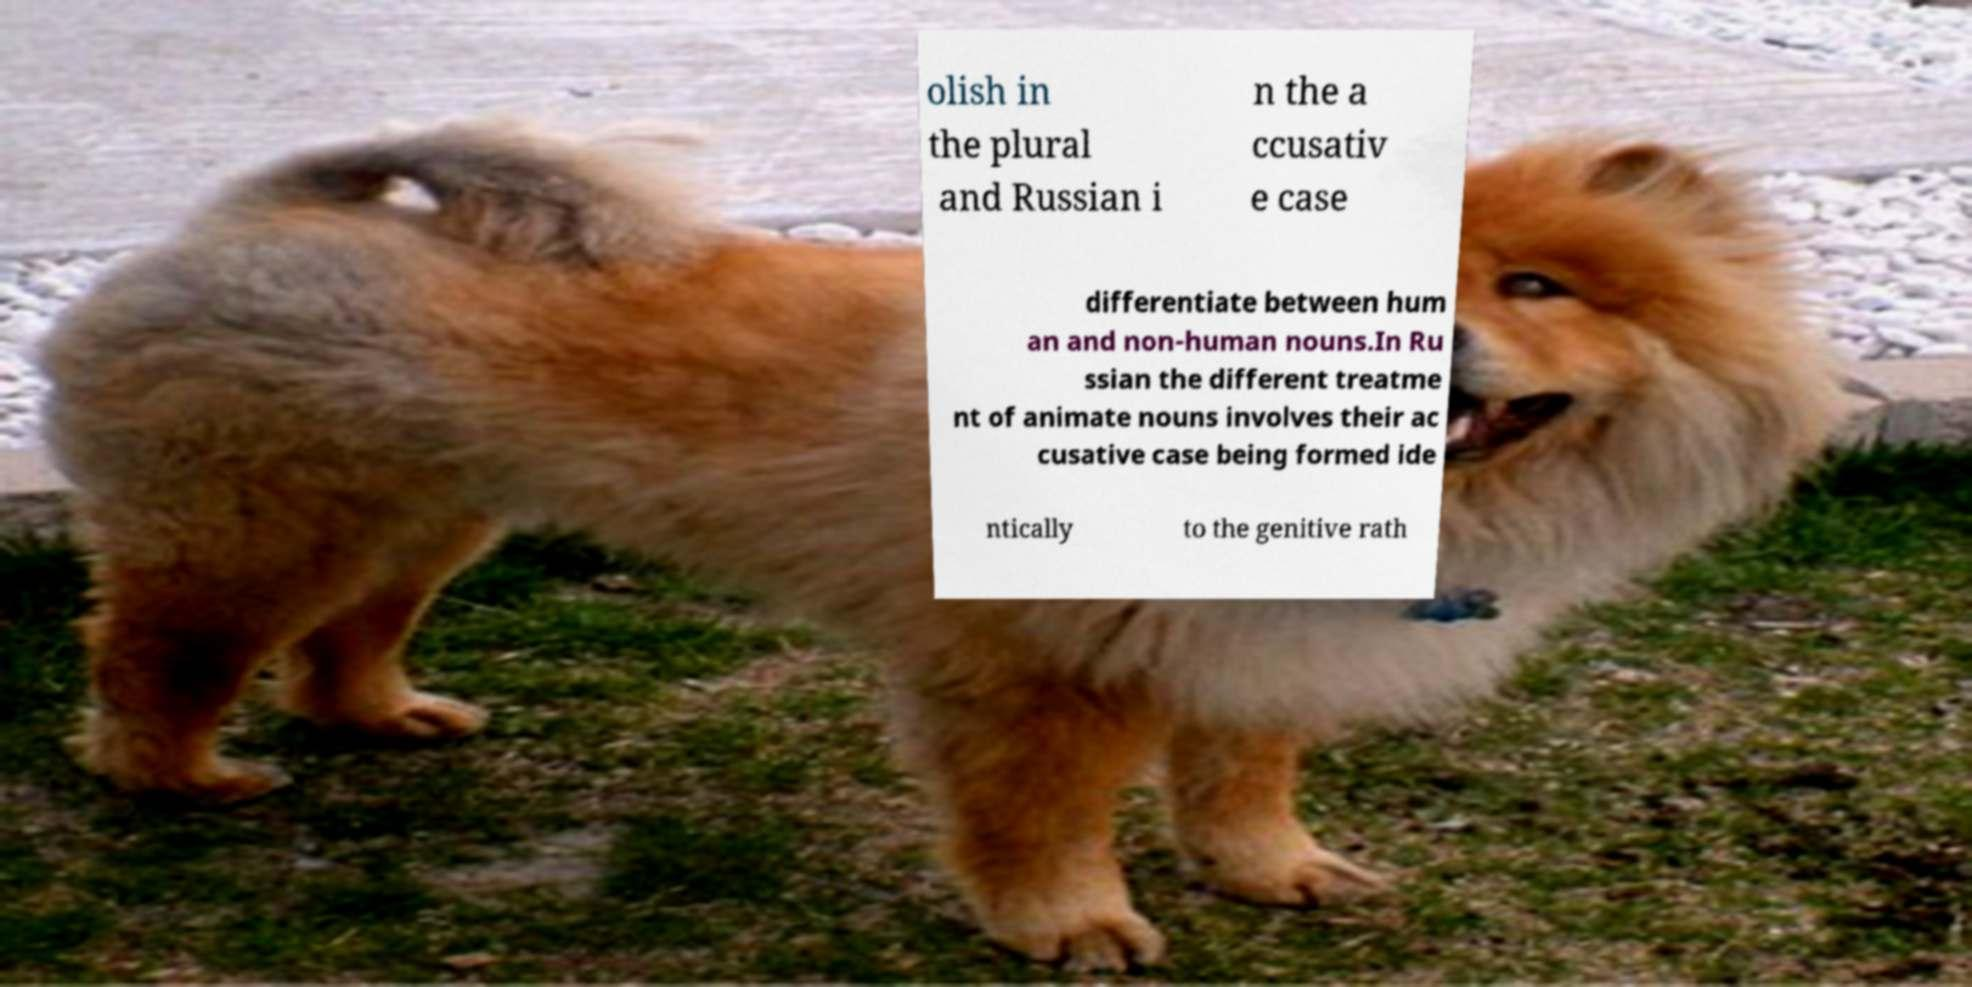Please identify and transcribe the text found in this image. olish in the plural and Russian i n the a ccusativ e case differentiate between hum an and non-human nouns.In Ru ssian the different treatme nt of animate nouns involves their ac cusative case being formed ide ntically to the genitive rath 